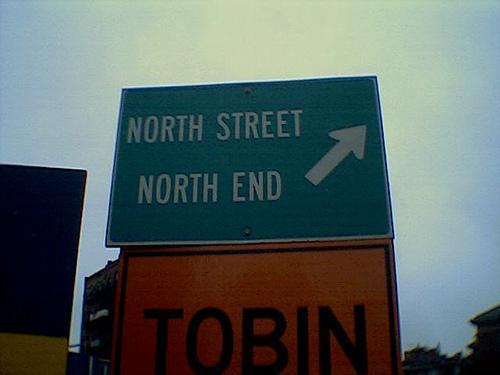How many stop signs are there?
Give a very brief answer. 0. 